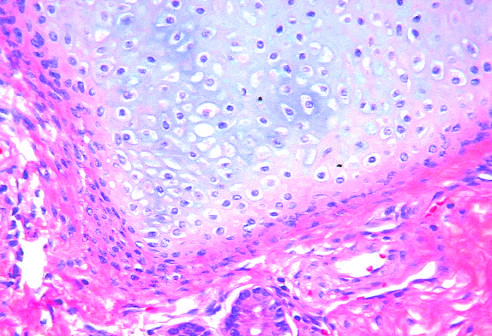what do testicular teratomas contain?
Answer the question using a single word or phrase. Mature cells from endodermal 